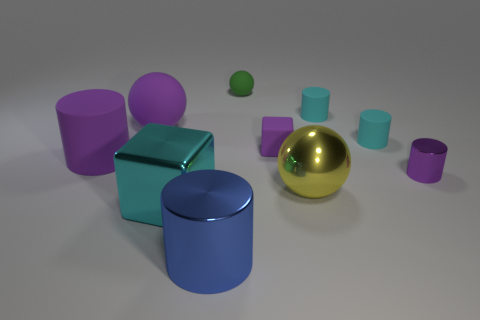There is a big cylinder that is the same color as the small matte block; what material is it?
Provide a succinct answer. Rubber. What is the material of the tiny object that is the same shape as the large cyan shiny thing?
Ensure brevity in your answer.  Rubber. What is the shape of the large yellow object?
Offer a very short reply. Sphere. There is a cylinder that is behind the yellow object and to the left of the tiny purple rubber thing; what material is it?
Give a very brief answer. Rubber. What is the shape of the large yellow thing that is made of the same material as the blue thing?
Offer a very short reply. Sphere. There is a ball that is the same material as the green object; what size is it?
Ensure brevity in your answer.  Large. What shape is the metallic thing that is to the right of the big cyan thing and in front of the big yellow object?
Your response must be concise. Cylinder. How big is the metallic thing left of the large blue metallic object in front of the large cyan metallic object?
Offer a very short reply. Large. How many other things are the same color as the tiny cube?
Your answer should be compact. 3. What material is the big yellow object?
Your answer should be compact. Metal. 